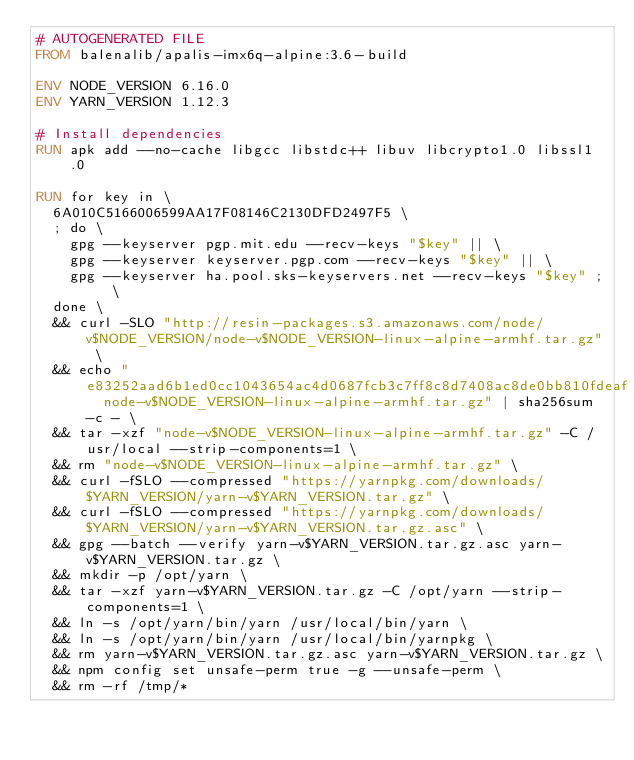<code> <loc_0><loc_0><loc_500><loc_500><_Dockerfile_># AUTOGENERATED FILE
FROM balenalib/apalis-imx6q-alpine:3.6-build

ENV NODE_VERSION 6.16.0
ENV YARN_VERSION 1.12.3

# Install dependencies
RUN apk add --no-cache libgcc libstdc++ libuv libcrypto1.0 libssl1.0

RUN for key in \
	6A010C5166006599AA17F08146C2130DFD2497F5 \
	; do \
		gpg --keyserver pgp.mit.edu --recv-keys "$key" || \
		gpg --keyserver keyserver.pgp.com --recv-keys "$key" || \
		gpg --keyserver ha.pool.sks-keyservers.net --recv-keys "$key" ; \
	done \
	&& curl -SLO "http://resin-packages.s3.amazonaws.com/node/v$NODE_VERSION/node-v$NODE_VERSION-linux-alpine-armhf.tar.gz" \
	&& echo "e83252aad6b1ed0cc1043654ac4d0687fcb3c7ff8c8d7408ac8de0bb810fdeaf  node-v$NODE_VERSION-linux-alpine-armhf.tar.gz" | sha256sum -c - \
	&& tar -xzf "node-v$NODE_VERSION-linux-alpine-armhf.tar.gz" -C /usr/local --strip-components=1 \
	&& rm "node-v$NODE_VERSION-linux-alpine-armhf.tar.gz" \
	&& curl -fSLO --compressed "https://yarnpkg.com/downloads/$YARN_VERSION/yarn-v$YARN_VERSION.tar.gz" \
	&& curl -fSLO --compressed "https://yarnpkg.com/downloads/$YARN_VERSION/yarn-v$YARN_VERSION.tar.gz.asc" \
	&& gpg --batch --verify yarn-v$YARN_VERSION.tar.gz.asc yarn-v$YARN_VERSION.tar.gz \
	&& mkdir -p /opt/yarn \
	&& tar -xzf yarn-v$YARN_VERSION.tar.gz -C /opt/yarn --strip-components=1 \
	&& ln -s /opt/yarn/bin/yarn /usr/local/bin/yarn \
	&& ln -s /opt/yarn/bin/yarn /usr/local/bin/yarnpkg \
	&& rm yarn-v$YARN_VERSION.tar.gz.asc yarn-v$YARN_VERSION.tar.gz \
	&& npm config set unsafe-perm true -g --unsafe-perm \
	&& rm -rf /tmp/*
</code> 